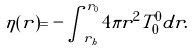Convert formula to latex. <formula><loc_0><loc_0><loc_500><loc_500>\eta ( r ) = - \int _ { r _ { h } } ^ { r _ { 0 } } 4 \pi r ^ { 2 } T ^ { 0 } _ { 0 } d r .</formula> 